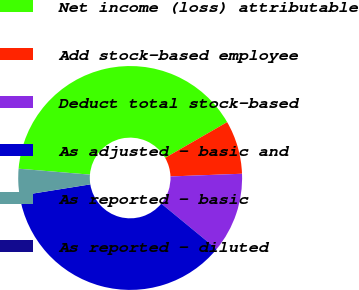Convert chart to OTSL. <chart><loc_0><loc_0><loc_500><loc_500><pie_chart><fcel>Net income (loss) attributable<fcel>Add stock-based employee<fcel>Deduct total stock-based<fcel>As adjusted - basic and<fcel>As reported - basic<fcel>As reported - diluted<nl><fcel>40.36%<fcel>7.71%<fcel>11.56%<fcel>36.51%<fcel>3.85%<fcel>0.0%<nl></chart> 